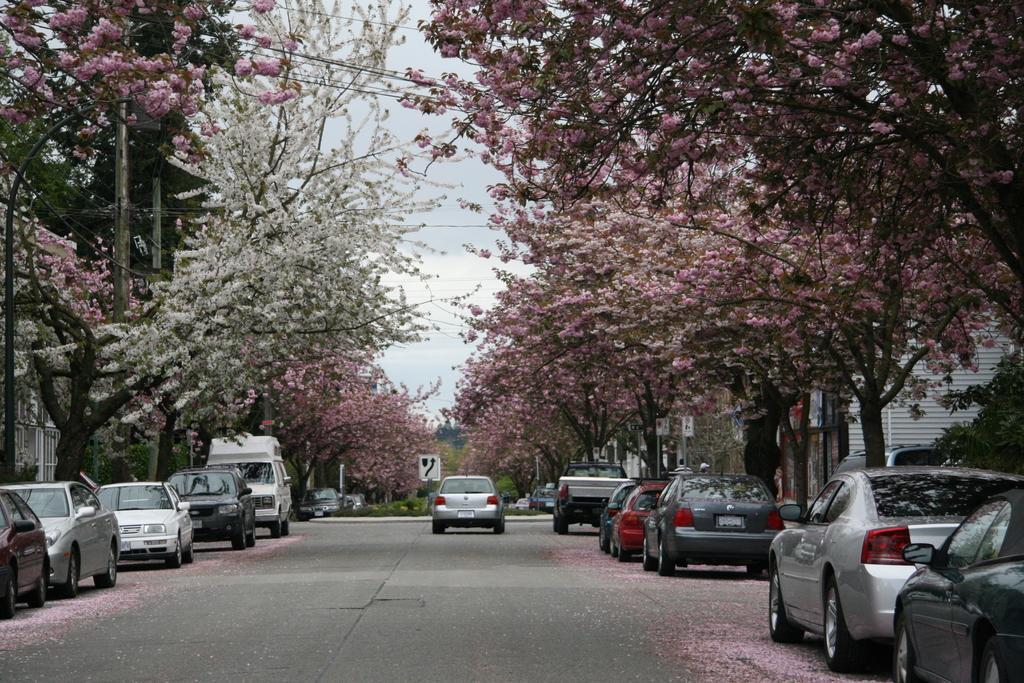Please provide a concise description of this image. On the right and left of the image there are buildings, trees, poles and sign boards, in front of them there are few vehicles parked to the side of a road and a vehicle is moving on the road. In the background there is the sky. 